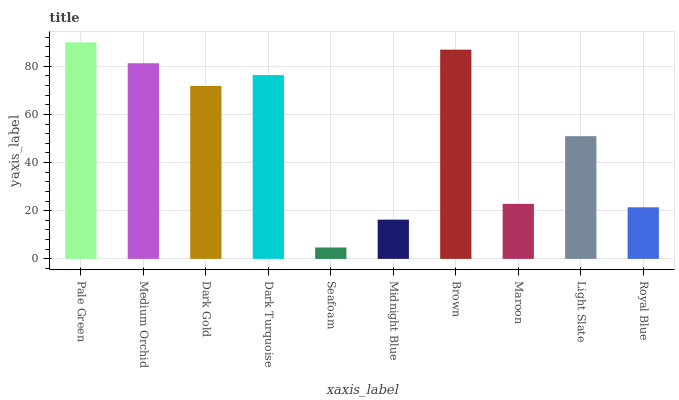Is Seafoam the minimum?
Answer yes or no. Yes. Is Pale Green the maximum?
Answer yes or no. Yes. Is Medium Orchid the minimum?
Answer yes or no. No. Is Medium Orchid the maximum?
Answer yes or no. No. Is Pale Green greater than Medium Orchid?
Answer yes or no. Yes. Is Medium Orchid less than Pale Green?
Answer yes or no. Yes. Is Medium Orchid greater than Pale Green?
Answer yes or no. No. Is Pale Green less than Medium Orchid?
Answer yes or no. No. Is Dark Gold the high median?
Answer yes or no. Yes. Is Light Slate the low median?
Answer yes or no. Yes. Is Pale Green the high median?
Answer yes or no. No. Is Seafoam the low median?
Answer yes or no. No. 